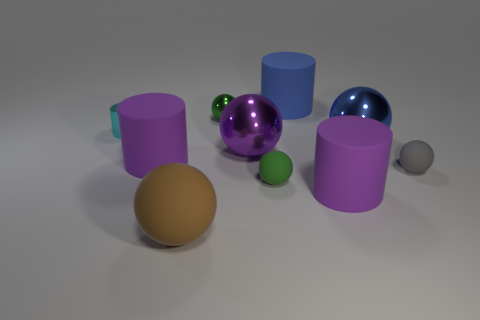Subtract 1 cylinders. How many cylinders are left? 3 Subtract all purple balls. How many balls are left? 5 Subtract all large brown spheres. How many spheres are left? 5 Subtract all gray cylinders. Subtract all cyan balls. How many cylinders are left? 4 Subtract all cylinders. How many objects are left? 6 Add 4 blue rubber cylinders. How many blue rubber cylinders are left? 5 Add 1 tiny brown cubes. How many tiny brown cubes exist? 1 Subtract 0 brown cylinders. How many objects are left? 10 Subtract all gray things. Subtract all yellow balls. How many objects are left? 9 